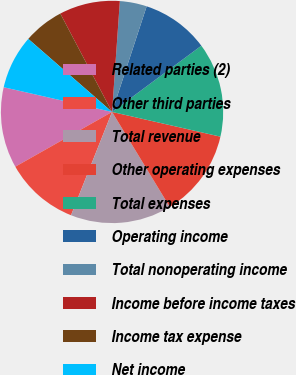<chart> <loc_0><loc_0><loc_500><loc_500><pie_chart><fcel>Related parties (2)<fcel>Other third parties<fcel>Total revenue<fcel>Other operating expenses<fcel>Total expenses<fcel>Operating income<fcel>Total nonoperating income<fcel>Income before income taxes<fcel>Income tax expense<fcel>Net income<nl><fcel>11.76%<fcel>10.78%<fcel>14.7%<fcel>12.74%<fcel>13.72%<fcel>9.8%<fcel>3.92%<fcel>8.82%<fcel>5.88%<fcel>7.84%<nl></chart> 